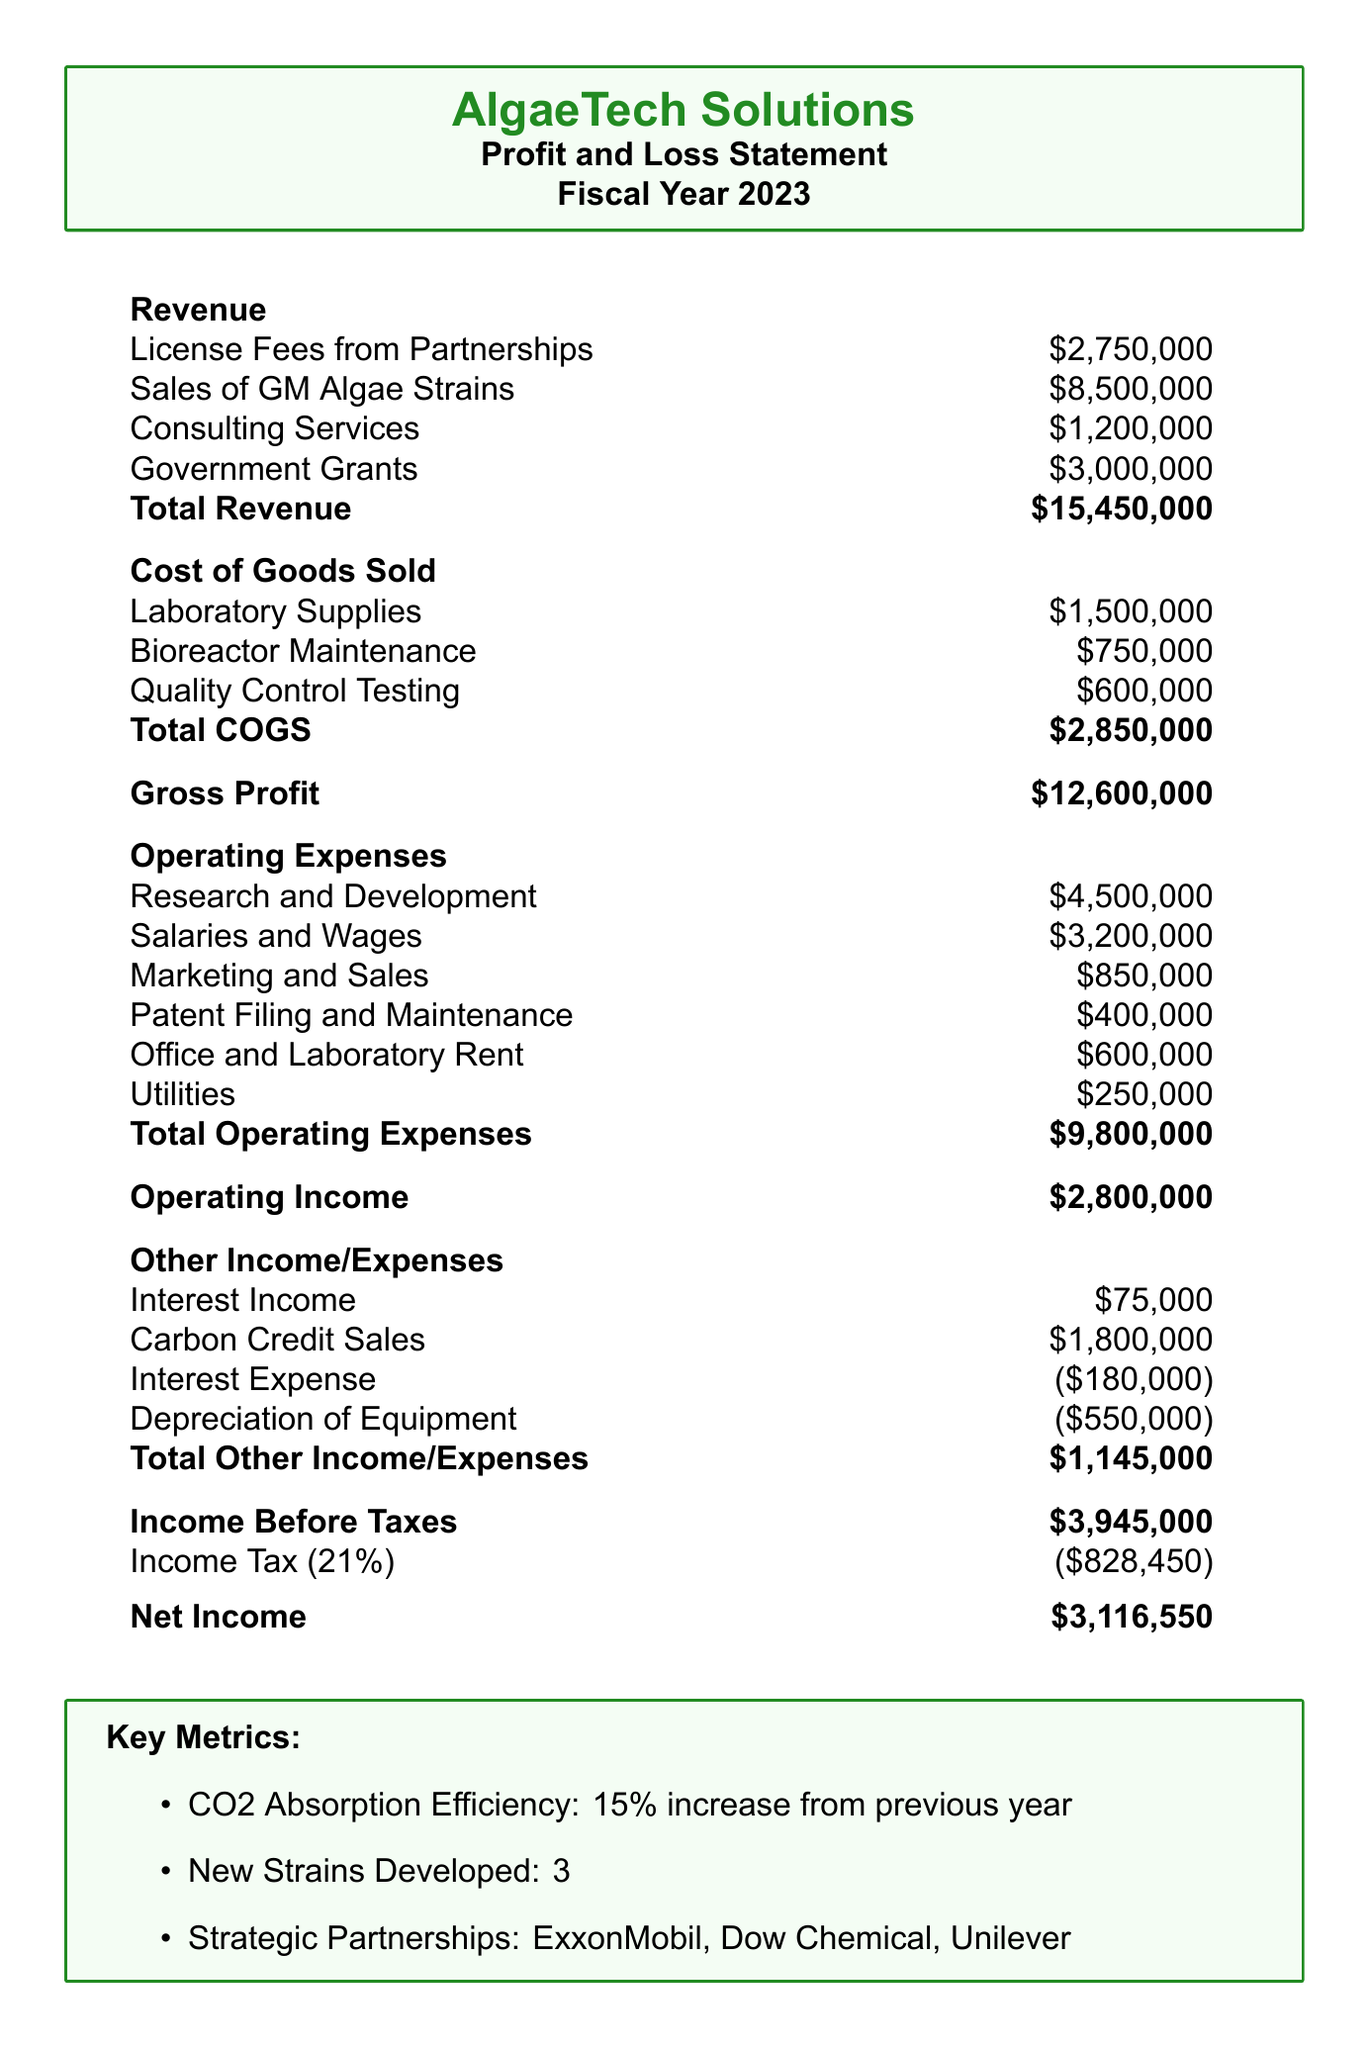what is the total revenue? The total revenue is the sum of all revenue sources in the document: $2,750,000 + $8,500,000 + $1,200,000 + $3,000,000 = $15,450,000.
Answer: $15,450,000 what are the total operating expenses? The total operating expenses can be calculated by summing all operating expense items listed in the document: $4,500,000 + $3,200,000 + $850,000 + $400,000 + $600,000 + $250,000 = $9,800,000.
Answer: $9,800,000 what is the net income? The net income is the result of subtracting income tax from income before taxes: $3,945,000 - $828,450 = $3,116,550.
Answer: $3,116,550 how much did the company earn from carbon credit sales? The document lists the carbon credit sales as one of the sources of other income.
Answer: $1,800,000 how many new strains of GM algae were developed? The document specifies that 3 new strains of GM algae were developed during the fiscal year.
Answer: 3 what percentage increase in CO2 absorption efficiency is reported? The document states there has been a 15% increase in CO2 absorption efficiency from the previous year.
Answer: 15% who are the strategic partners mentioned in the report? The document lists ExxonMobil, Dow Chemical, and Unilever as strategic partnerships.
Answer: ExxonMobil, Dow Chemical, Unilever what is the tax rate applied in the report? The tax rate specified in the document is 21%.
Answer: 21% what is the total cost of goods sold (COGS)? The total COGS is calculated by summing all costs associated with goods sold: $1,500,000 + $750,000 + $600,000 = $2,850,000.
Answer: $2,850,000 